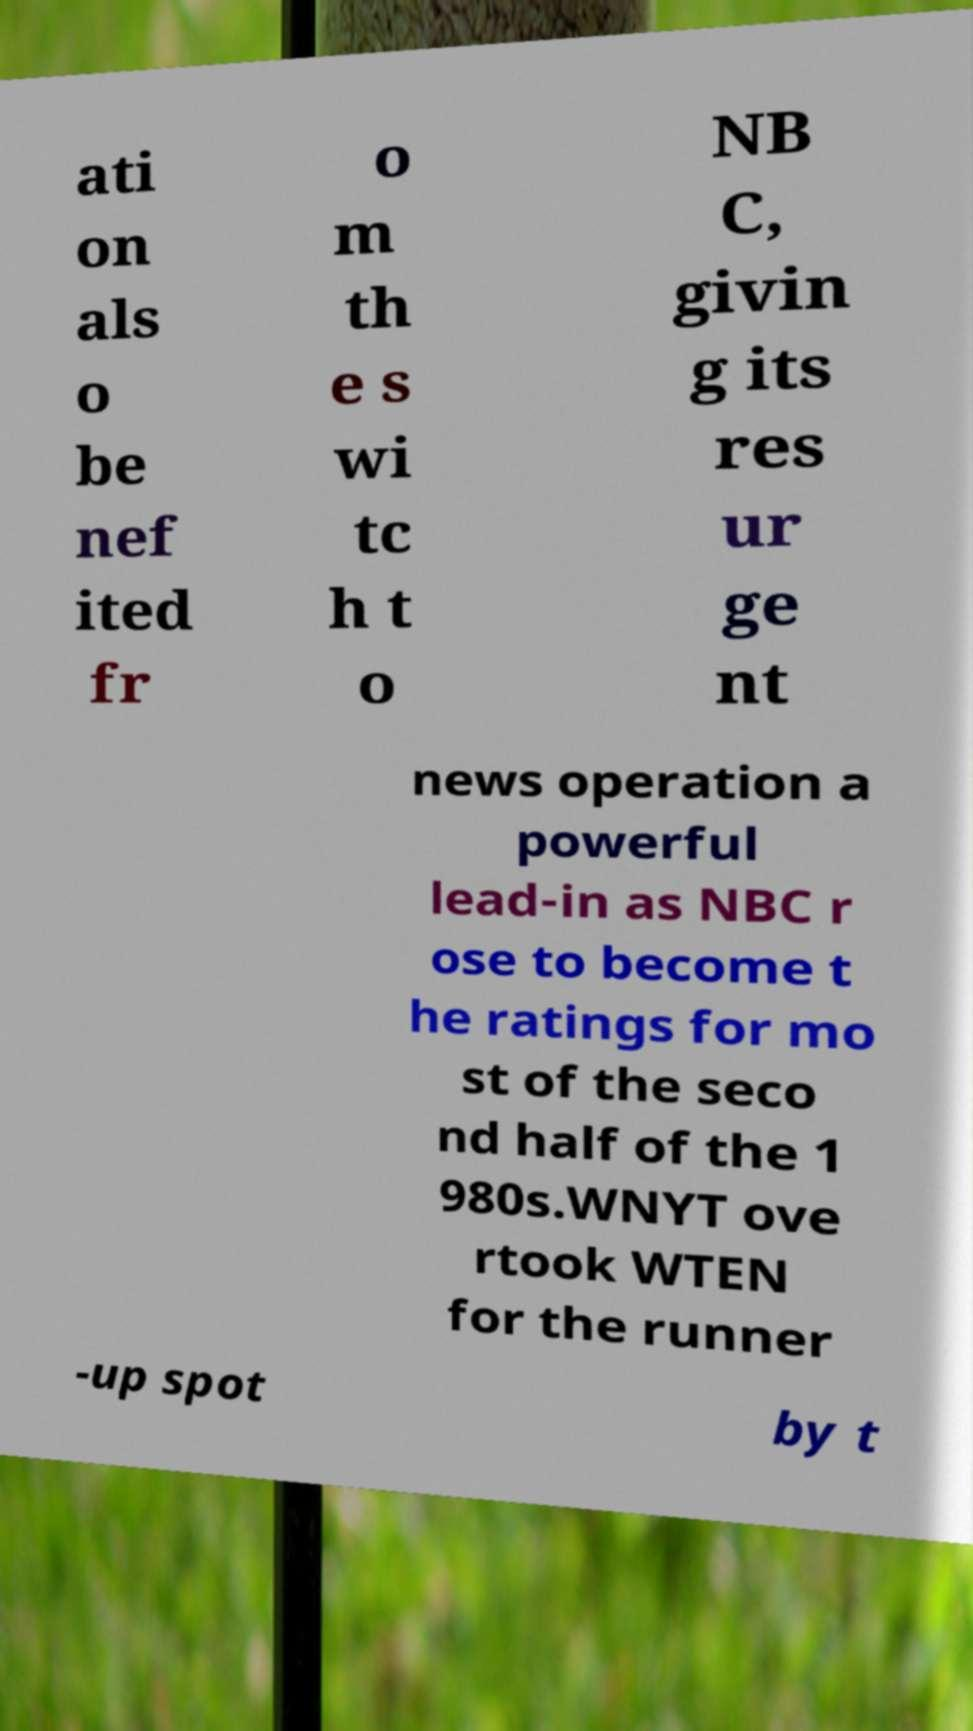What messages or text are displayed in this image? I need them in a readable, typed format. ati on als o be nef ited fr o m th e s wi tc h t o NB C, givin g its res ur ge nt news operation a powerful lead-in as NBC r ose to become t he ratings for mo st of the seco nd half of the 1 980s.WNYT ove rtook WTEN for the runner -up spot by t 